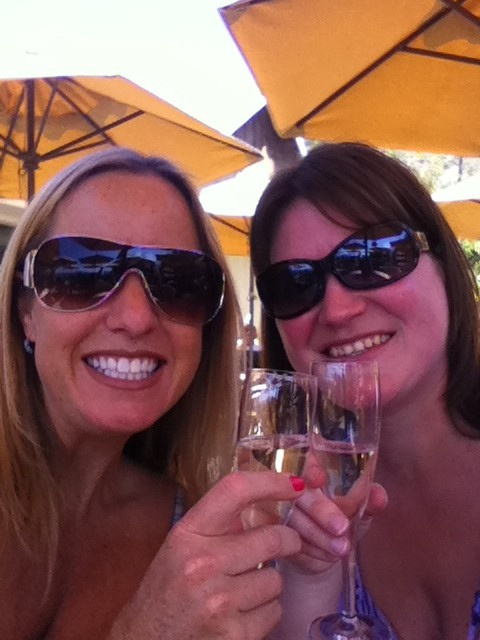Describe the objects in this image and their specific colors. I can see people in ivory, maroon, brown, and black tones, people in ivory, black, maroon, brown, and purple tones, umbrella in ivory, orange, and brown tones, umbrella in ivory, orange, brown, and maroon tones, and wine glass in ivory, purple, brown, and maroon tones in this image. 